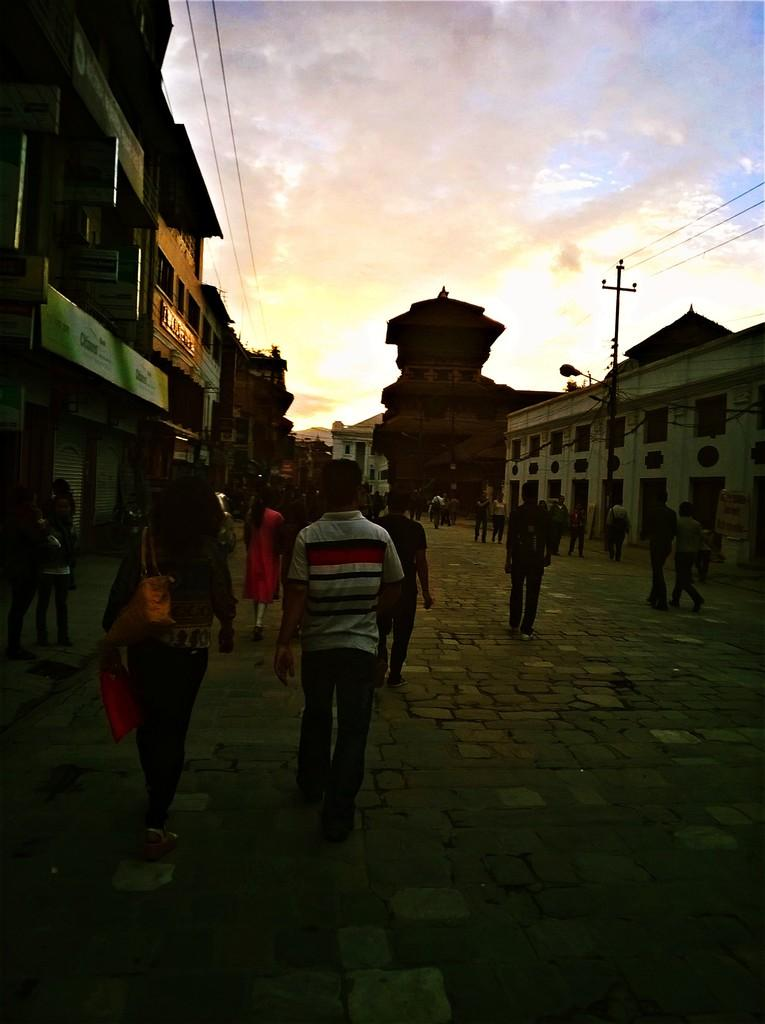How many people are in the image? There is a group of persons in the image. What are the people in the image doing? The group of persons is walking on the road. What can be seen in the background of the image? There are buildings, poles, and wires in the image. What is the condition of the sky in the image? The sky is cloudy in the image. Can you tell me how many mothers are present in the image? There is no information about mothers in the image; it only shows a group of persons walking on the road. Is there any quicksand visible in the image? There is no quicksand present in the image; it features a group of persons walking on a road with buildings, poles, and wires in the background. 